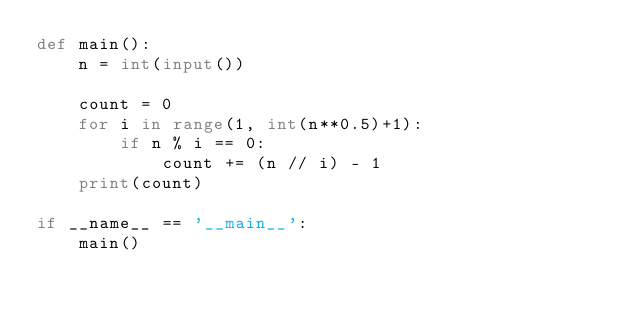Convert code to text. <code><loc_0><loc_0><loc_500><loc_500><_Python_>def main():
    n = int(input())

    count = 0
    for i in range(1, int(n**0.5)+1):
        if n % i == 0:
            count += (n // i) - 1
    print(count)

if __name__ == '__main__':
    main()
</code> 